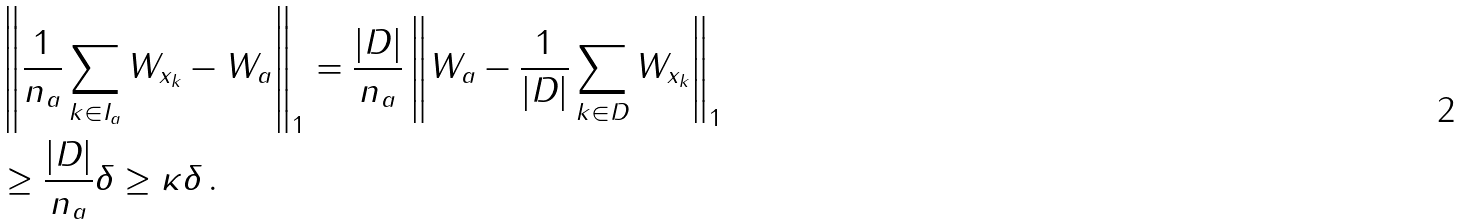Convert formula to latex. <formula><loc_0><loc_0><loc_500><loc_500>& \left \| \frac { 1 } { n _ { a } } \sum _ { k \in I _ { a } } W _ { x _ { k } } - W _ { a } \right \| _ { 1 } = \frac { | D | } { n _ { a } } \left \| W _ { a } - \frac { 1 } { | D | } \sum _ { k \in D } W _ { x _ { k } } \right \| _ { 1 } \\ & \geq \frac { | D | } { n _ { a } } \delta \geq \kappa \delta \, .</formula> 